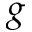<formula> <loc_0><loc_0><loc_500><loc_500>g</formula> 